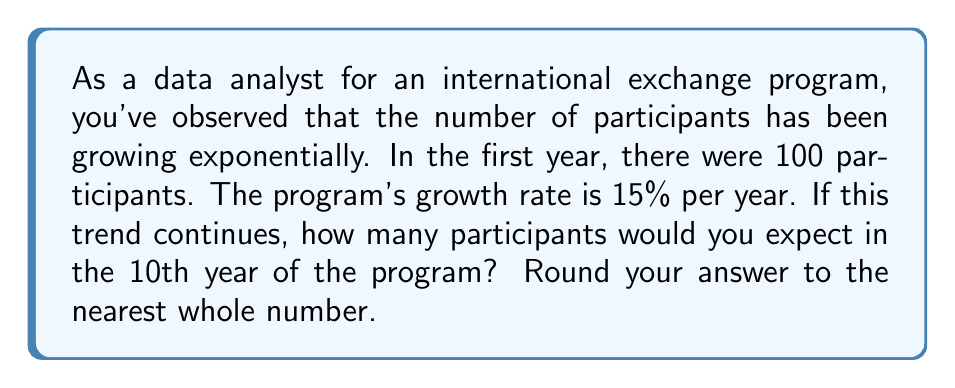Give your solution to this math problem. To solve this problem, we'll use the exponential growth formula:

$$A = P(1 + r)^t$$

Where:
$A$ = Final amount
$P$ = Initial principal balance
$r$ = Annual growth rate (in decimal form)
$t$ = Number of years

Given:
$P = 100$ (initial participants)
$r = 0.15$ (15% growth rate)
$t = 10$ (we want to know the number in the 10th year)

Let's plug these values into the formula:

$$A = 100(1 + 0.15)^{10}$$

Now, let's calculate step by step:

1) First, calculate $(1 + 0.15)$:
   $1 + 0.15 = 1.15$

2) Now, we have:
   $$A = 100(1.15)^{10}$$

3) Calculate $(1.15)^{10}$:
   $(1.15)^{10} \approx 4.0456$

4) Finally, multiply by 100:
   $100 * 4.0456 = 404.56$

5) Rounding to the nearest whole number:
   $404.56 \approx 405$

Therefore, in the 10th year of the program, you would expect approximately 405 participants.
Answer: 405 participants 